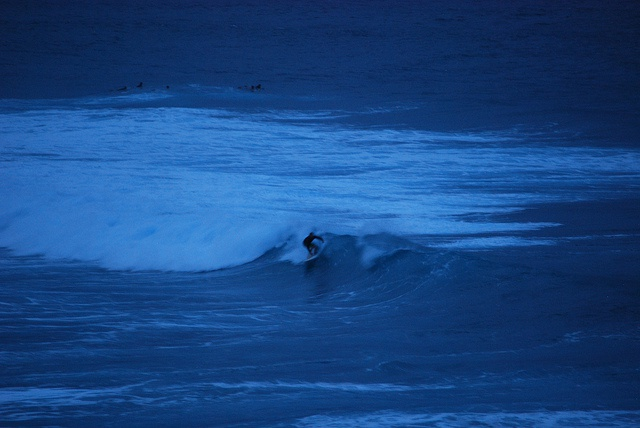Describe the objects in this image and their specific colors. I can see people in navy, black, blue, and darkblue tones, surfboard in navy, blue, darkblue, and gray tones, people in navy and black tones, people in black and navy tones, and people in navy, darkblue, and black tones in this image. 